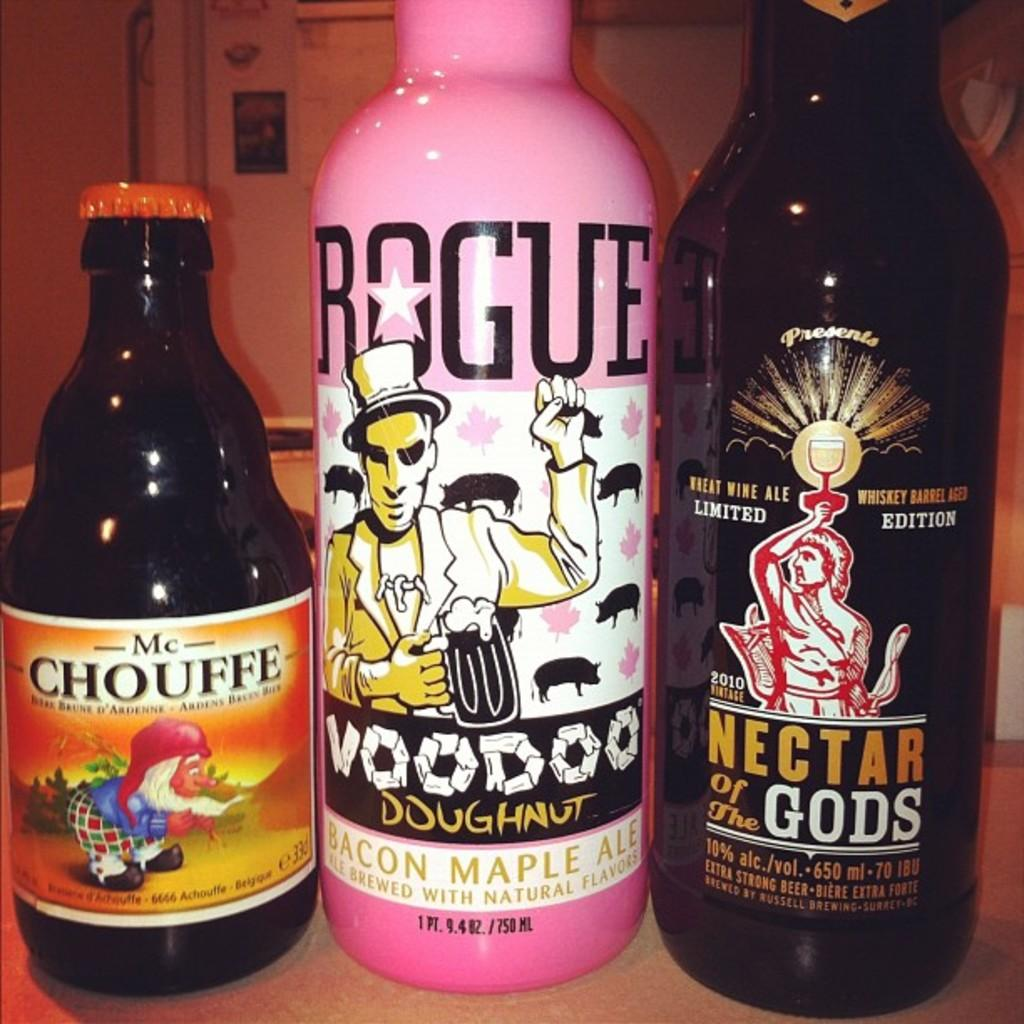<image>
Offer a succinct explanation of the picture presented. A bottle of Rogue VooDoo Doughnut bacon maple ale, a bottle of Nectar of the Gods wheat wine ale, and a bottle of McChouffe. 